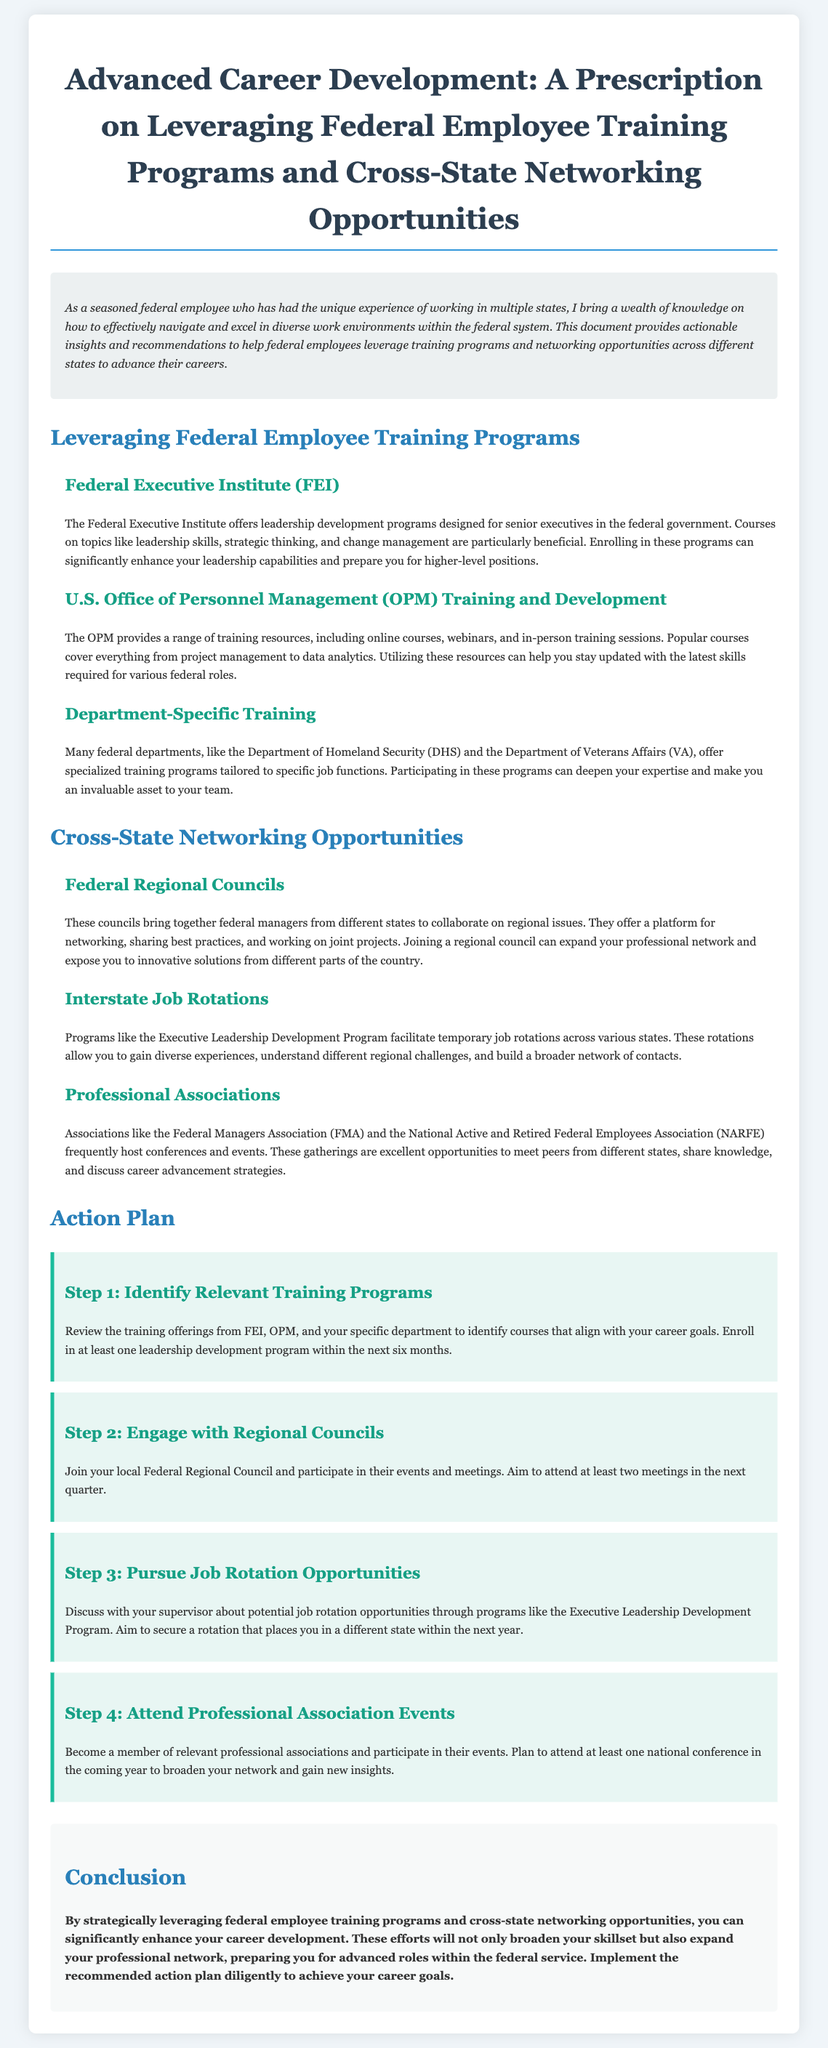What is the title of the document? The title of the document is presented prominently at the top of the content, providing insight into its focus area.
Answer: Advanced Career Development: A Prescription on Leveraging Federal Employee Training Programs and Cross-State Networking Opportunities How many sections are included in the document? The document is divided into distinct sections, each focusing on different key topics related to career development.
Answer: 3 What is one training program mentioned in the document? The document highlights various training programs available to federal employees, specifically mentioning notable ones for career advancement.
Answer: Federal Executive Institute What type of events do Professional Associations host? The document outlines the activities and opportunities provided by professional associations to facilitate networking and knowledge sharing among federal employees.
Answer: Conferences What is recommended as Step 1 in the action plan? The action plan section specifies concrete steps that individuals should take to progress their career development, starting with training program identification.
Answer: Identify Relevant Training Programs What is the aim of joining a Federal Regional Council? The document describes the purpose of Federal Regional Councils in promoting collaboration and networking among federal managers across different states.
Answer: Networking and sharing best practices In how many months should employees enroll in a leadership development program? The document includes a timeline for enrollment in leadership programs as part of the career development action steps outlined.
Answer: 6 months What type of job opportunities should be pursued according to Step 3? Step 3 specifically discusses gaining diverse experiences through temporary roles designed to enhance career development within federal service.
Answer: Job Rotation Opportunities What will broaden your skillset according to the conclusion? The conclusion emphasizes the benefits of certain actions regarding career development, highlighting areas of growth for federal employees.
Answer: Leveraging federal employee training programs and cross-state networking opportunities 